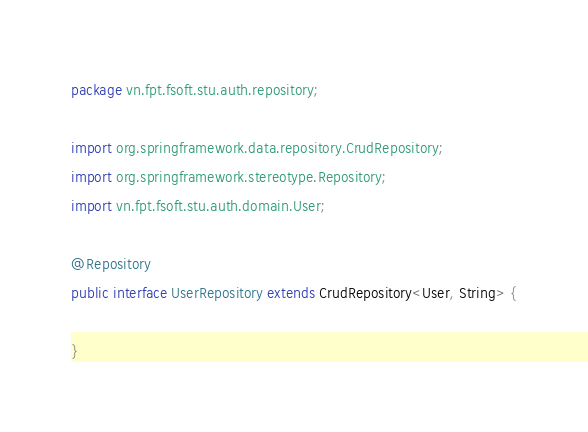Convert code to text. <code><loc_0><loc_0><loc_500><loc_500><_Java_>package vn.fpt.fsoft.stu.auth.repository;

import org.springframework.data.repository.CrudRepository;
import org.springframework.stereotype.Repository;
import vn.fpt.fsoft.stu.auth.domain.User;

@Repository
public interface UserRepository extends CrudRepository<User, String> {

}
</code> 